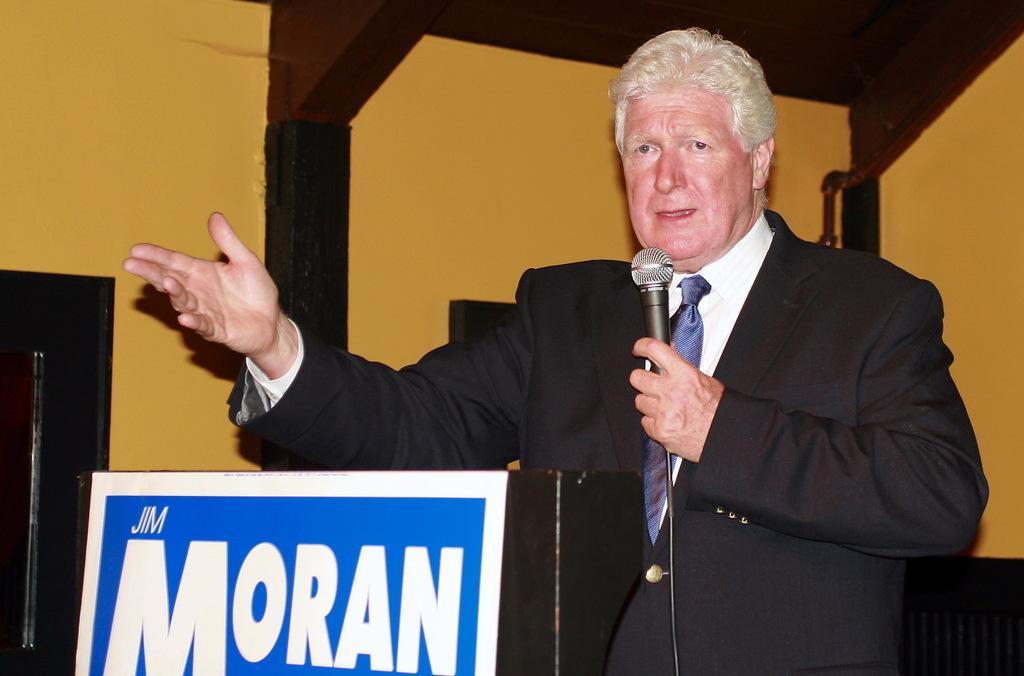In one or two sentences, can you explain what this image depicts? In this image, at the right side there is a man standing and he is wearing a black color coat, he is holding a microphone, at the left side there is a blue color poster on that MORAN is printed, at the background there is a yellow color wall. 